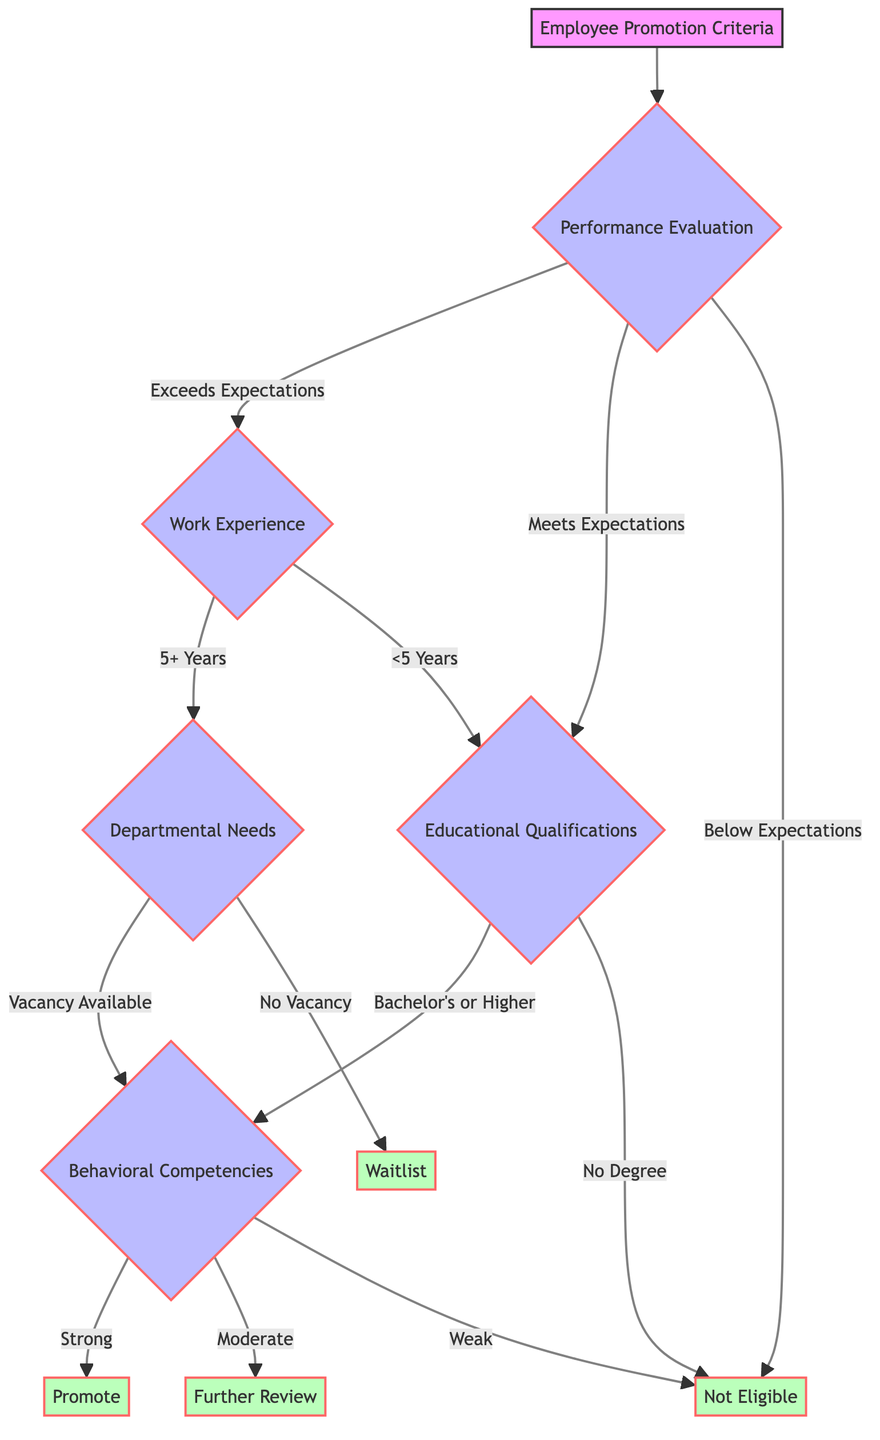What are the three categories of Performance Evaluation? The diagram indicates that Performance Evaluation comprises three categories: Yearly Rating, Peer Reviews, and Manager Feedback.
Answer: Yearly Rating, Peer Reviews, Manager Feedback If an employee's performance evaluation is "Exceeds Expectations," what is the next criterion they are assessed on? Based on the diagram, if an employee receives "Exceeds Expectations" in their performance evaluation, the next criterion they move to is Work Experience.
Answer: Work Experience What happens if an employee is rated "Below Expectations"? According to the flow in the diagram, if an employee receives a rating of "Below Expectations," they are directly classified as Not Eligible for promotion.
Answer: Not Eligible How many types of Work Experience are considered in the diagram? The diagram identifies two main components within Work Experience: Years of Service and Previous Roles, indicating that there are multiple aspects to consider.
Answer: Two What degree is required to progress from Educational Qualifications to Behavioral Competencies? The diagram specifies that an employee must have at least a Bachelor's degree to advance from Educational Qualifications to the Behavioral Competencies.
Answer: Bachelor's What occurs if there are no vacancies available in Departmental Needs after the Work Experience assessment? According to the diagram, if there are no vacancies available after assessing Departmental Needs, the employee will be placed on a Waitlist for promotion consideration.
Answer: Waitlist What is the outcome for an employee with "Weak" behavioral competencies? The diagram states that if an employee has "Weak" behavioral competencies, they are classified as Not Eligible for promotion.
Answer: Not Eligible If an employee has "5+ Years" of Work Experience and there is a vacancy, what is the next assessment area? The diagram indicates that if an employee has "5+ Years" of Work Experience and a vacancy exists, they will move on to assess Behavioral Competencies next.
Answer: Behavioral Competencies What determines whether an employee is promoted after all assessments? The promotion decision ultimately depends on the outcomes of the Behavioral Competencies assessment, particularly if they have Strong, Moderate, or Weak ratings. Strong leads to Promote, Moderate to Further Review, and Weak leads to Not Eligible.
Answer: Strong, Moderate, Weak 